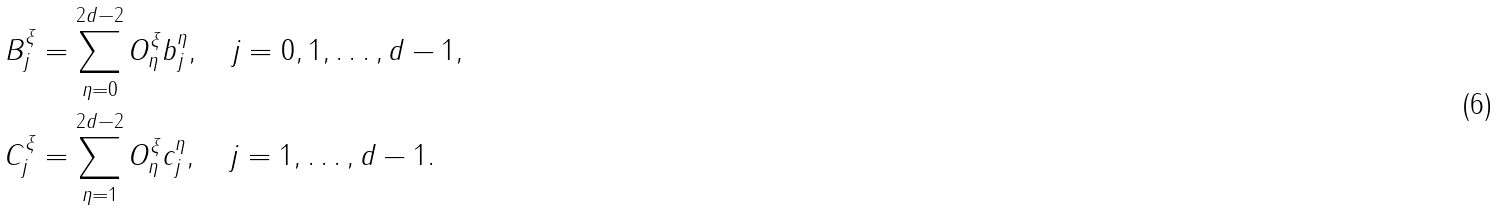Convert formula to latex. <formula><loc_0><loc_0><loc_500><loc_500>B ^ { \xi } _ { j } & = \sum _ { \eta = 0 } ^ { 2 d - 2 } O ^ { \xi } _ { \eta } b _ { j } ^ { \eta } , \quad j = 0 , 1 , \dots , d - 1 , \\ C ^ { \xi } _ { j } & = \sum _ { \eta = 1 } ^ { 2 d - 2 } O ^ { \xi } _ { \eta } c _ { j } ^ { \eta } , \quad j = 1 , \dots , d - 1 .</formula> 